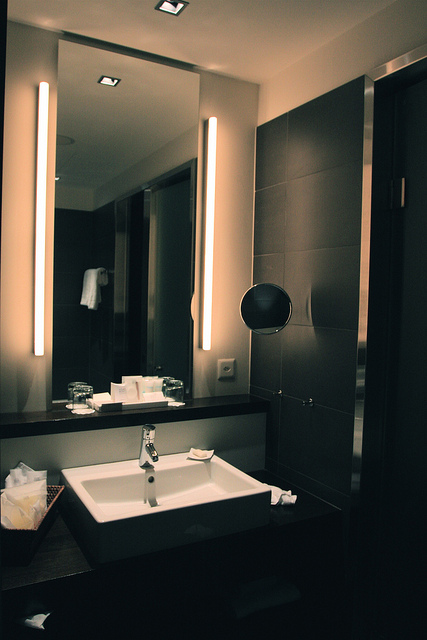Can you discuss any events or actions that might be happening in the image? The image depicts a calm and serene bathroom setting. While there is no direct evidence of any actions occurring, the presence of items like soap near the sink and the lighting being turned on suggest that someone might have recently used or is about to use the bathroom. The overall ambiance implies cleanliness and readiness for use at any moment. 